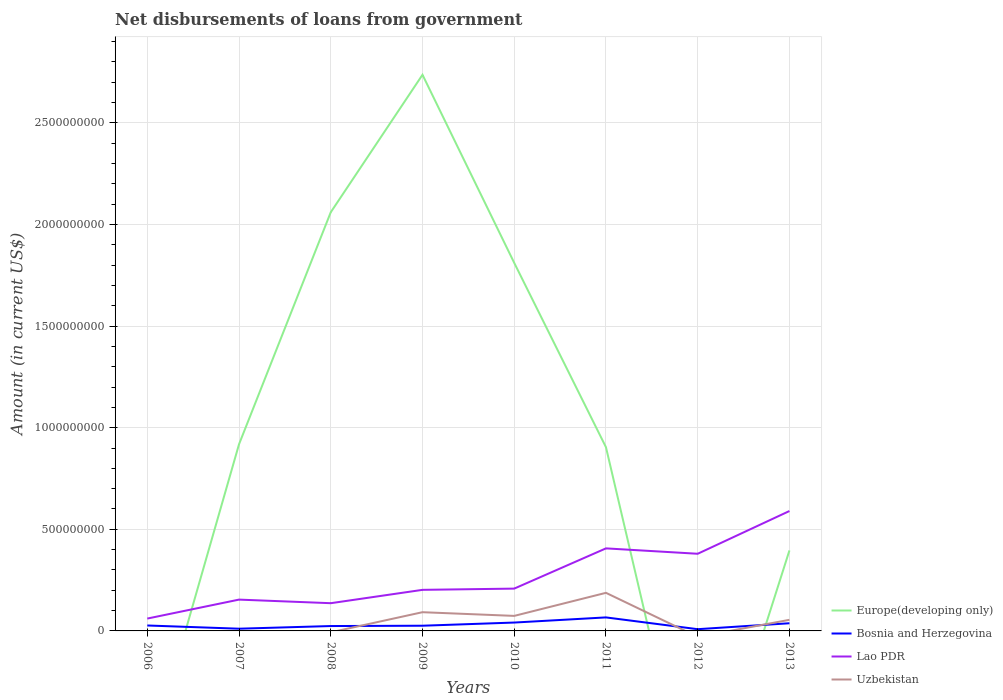Is the number of lines equal to the number of legend labels?
Keep it short and to the point. No. Across all years, what is the maximum amount of loan disbursed from government in Bosnia and Herzegovina?
Your answer should be compact. 8.51e+06. What is the total amount of loan disbursed from government in Lao PDR in the graph?
Your answer should be very brief. 1.76e+07. What is the difference between the highest and the second highest amount of loan disbursed from government in Bosnia and Herzegovina?
Provide a short and direct response. 5.80e+07. What is the difference between the highest and the lowest amount of loan disbursed from government in Europe(developing only)?
Provide a succinct answer. 3. Is the amount of loan disbursed from government in Uzbekistan strictly greater than the amount of loan disbursed from government in Bosnia and Herzegovina over the years?
Offer a terse response. No. How many lines are there?
Offer a very short reply. 4. What is the difference between two consecutive major ticks on the Y-axis?
Your answer should be compact. 5.00e+08. Does the graph contain any zero values?
Provide a succinct answer. Yes. How are the legend labels stacked?
Offer a terse response. Vertical. What is the title of the graph?
Your answer should be very brief. Net disbursements of loans from government. What is the Amount (in current US$) in Bosnia and Herzegovina in 2006?
Offer a very short reply. 2.67e+07. What is the Amount (in current US$) of Lao PDR in 2006?
Your response must be concise. 6.08e+07. What is the Amount (in current US$) in Uzbekistan in 2006?
Your answer should be compact. 0. What is the Amount (in current US$) in Europe(developing only) in 2007?
Make the answer very short. 9.19e+08. What is the Amount (in current US$) in Bosnia and Herzegovina in 2007?
Your answer should be compact. 1.09e+07. What is the Amount (in current US$) of Lao PDR in 2007?
Provide a short and direct response. 1.54e+08. What is the Amount (in current US$) of Uzbekistan in 2007?
Give a very brief answer. 0. What is the Amount (in current US$) in Europe(developing only) in 2008?
Provide a short and direct response. 2.06e+09. What is the Amount (in current US$) of Bosnia and Herzegovina in 2008?
Ensure brevity in your answer.  2.40e+07. What is the Amount (in current US$) in Lao PDR in 2008?
Offer a very short reply. 1.36e+08. What is the Amount (in current US$) of Uzbekistan in 2008?
Offer a very short reply. 0. What is the Amount (in current US$) of Europe(developing only) in 2009?
Offer a very short reply. 2.74e+09. What is the Amount (in current US$) of Bosnia and Herzegovina in 2009?
Provide a succinct answer. 2.56e+07. What is the Amount (in current US$) of Lao PDR in 2009?
Make the answer very short. 2.02e+08. What is the Amount (in current US$) in Uzbekistan in 2009?
Give a very brief answer. 9.21e+07. What is the Amount (in current US$) in Europe(developing only) in 2010?
Your answer should be very brief. 1.81e+09. What is the Amount (in current US$) in Bosnia and Herzegovina in 2010?
Provide a succinct answer. 4.12e+07. What is the Amount (in current US$) in Lao PDR in 2010?
Ensure brevity in your answer.  2.08e+08. What is the Amount (in current US$) of Uzbekistan in 2010?
Keep it short and to the point. 7.39e+07. What is the Amount (in current US$) of Europe(developing only) in 2011?
Keep it short and to the point. 9.04e+08. What is the Amount (in current US$) of Bosnia and Herzegovina in 2011?
Give a very brief answer. 6.65e+07. What is the Amount (in current US$) of Lao PDR in 2011?
Give a very brief answer. 4.06e+08. What is the Amount (in current US$) of Uzbekistan in 2011?
Provide a succinct answer. 1.87e+08. What is the Amount (in current US$) in Europe(developing only) in 2012?
Offer a very short reply. 0. What is the Amount (in current US$) in Bosnia and Herzegovina in 2012?
Offer a terse response. 8.51e+06. What is the Amount (in current US$) of Lao PDR in 2012?
Your answer should be compact. 3.80e+08. What is the Amount (in current US$) in Europe(developing only) in 2013?
Your response must be concise. 3.96e+08. What is the Amount (in current US$) of Bosnia and Herzegovina in 2013?
Your answer should be very brief. 3.77e+07. What is the Amount (in current US$) in Lao PDR in 2013?
Give a very brief answer. 5.90e+08. What is the Amount (in current US$) in Uzbekistan in 2013?
Provide a short and direct response. 5.46e+07. Across all years, what is the maximum Amount (in current US$) in Europe(developing only)?
Ensure brevity in your answer.  2.74e+09. Across all years, what is the maximum Amount (in current US$) of Bosnia and Herzegovina?
Your answer should be very brief. 6.65e+07. Across all years, what is the maximum Amount (in current US$) in Lao PDR?
Your answer should be compact. 5.90e+08. Across all years, what is the maximum Amount (in current US$) in Uzbekistan?
Offer a very short reply. 1.87e+08. Across all years, what is the minimum Amount (in current US$) in Bosnia and Herzegovina?
Provide a short and direct response. 8.51e+06. Across all years, what is the minimum Amount (in current US$) in Lao PDR?
Offer a very short reply. 6.08e+07. Across all years, what is the minimum Amount (in current US$) of Uzbekistan?
Your response must be concise. 0. What is the total Amount (in current US$) of Europe(developing only) in the graph?
Make the answer very short. 8.83e+09. What is the total Amount (in current US$) in Bosnia and Herzegovina in the graph?
Your answer should be compact. 2.41e+08. What is the total Amount (in current US$) of Lao PDR in the graph?
Your answer should be very brief. 2.14e+09. What is the total Amount (in current US$) of Uzbekistan in the graph?
Your answer should be compact. 4.08e+08. What is the difference between the Amount (in current US$) in Bosnia and Herzegovina in 2006 and that in 2007?
Offer a very short reply. 1.58e+07. What is the difference between the Amount (in current US$) of Lao PDR in 2006 and that in 2007?
Your answer should be compact. -9.33e+07. What is the difference between the Amount (in current US$) in Bosnia and Herzegovina in 2006 and that in 2008?
Your answer should be very brief. 2.72e+06. What is the difference between the Amount (in current US$) of Lao PDR in 2006 and that in 2008?
Your answer should be very brief. -7.57e+07. What is the difference between the Amount (in current US$) of Bosnia and Herzegovina in 2006 and that in 2009?
Keep it short and to the point. 1.17e+06. What is the difference between the Amount (in current US$) of Lao PDR in 2006 and that in 2009?
Give a very brief answer. -1.41e+08. What is the difference between the Amount (in current US$) of Bosnia and Herzegovina in 2006 and that in 2010?
Make the answer very short. -1.44e+07. What is the difference between the Amount (in current US$) in Lao PDR in 2006 and that in 2010?
Provide a succinct answer. -1.47e+08. What is the difference between the Amount (in current US$) in Bosnia and Herzegovina in 2006 and that in 2011?
Offer a terse response. -3.97e+07. What is the difference between the Amount (in current US$) in Lao PDR in 2006 and that in 2011?
Provide a succinct answer. -3.45e+08. What is the difference between the Amount (in current US$) of Bosnia and Herzegovina in 2006 and that in 2012?
Provide a short and direct response. 1.82e+07. What is the difference between the Amount (in current US$) of Lao PDR in 2006 and that in 2012?
Keep it short and to the point. -3.19e+08. What is the difference between the Amount (in current US$) of Bosnia and Herzegovina in 2006 and that in 2013?
Offer a very short reply. -1.10e+07. What is the difference between the Amount (in current US$) in Lao PDR in 2006 and that in 2013?
Ensure brevity in your answer.  -5.29e+08. What is the difference between the Amount (in current US$) in Europe(developing only) in 2007 and that in 2008?
Your response must be concise. -1.14e+09. What is the difference between the Amount (in current US$) in Bosnia and Herzegovina in 2007 and that in 2008?
Provide a short and direct response. -1.31e+07. What is the difference between the Amount (in current US$) in Lao PDR in 2007 and that in 2008?
Ensure brevity in your answer.  1.76e+07. What is the difference between the Amount (in current US$) in Europe(developing only) in 2007 and that in 2009?
Keep it short and to the point. -1.82e+09. What is the difference between the Amount (in current US$) of Bosnia and Herzegovina in 2007 and that in 2009?
Give a very brief answer. -1.46e+07. What is the difference between the Amount (in current US$) in Lao PDR in 2007 and that in 2009?
Provide a succinct answer. -4.80e+07. What is the difference between the Amount (in current US$) in Europe(developing only) in 2007 and that in 2010?
Give a very brief answer. -8.92e+08. What is the difference between the Amount (in current US$) in Bosnia and Herzegovina in 2007 and that in 2010?
Your answer should be compact. -3.02e+07. What is the difference between the Amount (in current US$) in Lao PDR in 2007 and that in 2010?
Your answer should be very brief. -5.42e+07. What is the difference between the Amount (in current US$) in Europe(developing only) in 2007 and that in 2011?
Keep it short and to the point. 1.46e+07. What is the difference between the Amount (in current US$) in Bosnia and Herzegovina in 2007 and that in 2011?
Your answer should be very brief. -5.56e+07. What is the difference between the Amount (in current US$) of Lao PDR in 2007 and that in 2011?
Make the answer very short. -2.52e+08. What is the difference between the Amount (in current US$) of Bosnia and Herzegovina in 2007 and that in 2012?
Your answer should be compact. 2.42e+06. What is the difference between the Amount (in current US$) of Lao PDR in 2007 and that in 2012?
Provide a short and direct response. -2.26e+08. What is the difference between the Amount (in current US$) in Europe(developing only) in 2007 and that in 2013?
Give a very brief answer. 5.22e+08. What is the difference between the Amount (in current US$) of Bosnia and Herzegovina in 2007 and that in 2013?
Ensure brevity in your answer.  -2.68e+07. What is the difference between the Amount (in current US$) in Lao PDR in 2007 and that in 2013?
Make the answer very short. -4.36e+08. What is the difference between the Amount (in current US$) of Europe(developing only) in 2008 and that in 2009?
Offer a very short reply. -6.76e+08. What is the difference between the Amount (in current US$) in Bosnia and Herzegovina in 2008 and that in 2009?
Provide a succinct answer. -1.55e+06. What is the difference between the Amount (in current US$) in Lao PDR in 2008 and that in 2009?
Provide a short and direct response. -6.57e+07. What is the difference between the Amount (in current US$) in Europe(developing only) in 2008 and that in 2010?
Give a very brief answer. 2.49e+08. What is the difference between the Amount (in current US$) in Bosnia and Herzegovina in 2008 and that in 2010?
Give a very brief answer. -1.72e+07. What is the difference between the Amount (in current US$) of Lao PDR in 2008 and that in 2010?
Ensure brevity in your answer.  -7.18e+07. What is the difference between the Amount (in current US$) in Europe(developing only) in 2008 and that in 2011?
Your answer should be very brief. 1.16e+09. What is the difference between the Amount (in current US$) in Bosnia and Herzegovina in 2008 and that in 2011?
Your answer should be compact. -4.25e+07. What is the difference between the Amount (in current US$) of Lao PDR in 2008 and that in 2011?
Give a very brief answer. -2.70e+08. What is the difference between the Amount (in current US$) in Bosnia and Herzegovina in 2008 and that in 2012?
Your answer should be compact. 1.55e+07. What is the difference between the Amount (in current US$) of Lao PDR in 2008 and that in 2012?
Give a very brief answer. -2.43e+08. What is the difference between the Amount (in current US$) of Europe(developing only) in 2008 and that in 2013?
Provide a succinct answer. 1.66e+09. What is the difference between the Amount (in current US$) of Bosnia and Herzegovina in 2008 and that in 2013?
Your answer should be very brief. -1.37e+07. What is the difference between the Amount (in current US$) in Lao PDR in 2008 and that in 2013?
Your answer should be very brief. -4.53e+08. What is the difference between the Amount (in current US$) in Europe(developing only) in 2009 and that in 2010?
Keep it short and to the point. 9.26e+08. What is the difference between the Amount (in current US$) in Bosnia and Herzegovina in 2009 and that in 2010?
Offer a very short reply. -1.56e+07. What is the difference between the Amount (in current US$) in Lao PDR in 2009 and that in 2010?
Ensure brevity in your answer.  -6.12e+06. What is the difference between the Amount (in current US$) of Uzbekistan in 2009 and that in 2010?
Ensure brevity in your answer.  1.82e+07. What is the difference between the Amount (in current US$) in Europe(developing only) in 2009 and that in 2011?
Your response must be concise. 1.83e+09. What is the difference between the Amount (in current US$) in Bosnia and Herzegovina in 2009 and that in 2011?
Provide a succinct answer. -4.09e+07. What is the difference between the Amount (in current US$) in Lao PDR in 2009 and that in 2011?
Provide a succinct answer. -2.04e+08. What is the difference between the Amount (in current US$) in Uzbekistan in 2009 and that in 2011?
Give a very brief answer. -9.53e+07. What is the difference between the Amount (in current US$) of Bosnia and Herzegovina in 2009 and that in 2012?
Your answer should be compact. 1.71e+07. What is the difference between the Amount (in current US$) of Lao PDR in 2009 and that in 2012?
Ensure brevity in your answer.  -1.78e+08. What is the difference between the Amount (in current US$) in Europe(developing only) in 2009 and that in 2013?
Your response must be concise. 2.34e+09. What is the difference between the Amount (in current US$) in Bosnia and Herzegovina in 2009 and that in 2013?
Provide a short and direct response. -1.22e+07. What is the difference between the Amount (in current US$) in Lao PDR in 2009 and that in 2013?
Offer a terse response. -3.88e+08. What is the difference between the Amount (in current US$) in Uzbekistan in 2009 and that in 2013?
Provide a succinct answer. 3.75e+07. What is the difference between the Amount (in current US$) in Europe(developing only) in 2010 and that in 2011?
Keep it short and to the point. 9.07e+08. What is the difference between the Amount (in current US$) of Bosnia and Herzegovina in 2010 and that in 2011?
Keep it short and to the point. -2.53e+07. What is the difference between the Amount (in current US$) of Lao PDR in 2010 and that in 2011?
Your answer should be very brief. -1.98e+08. What is the difference between the Amount (in current US$) of Uzbekistan in 2010 and that in 2011?
Offer a very short reply. -1.14e+08. What is the difference between the Amount (in current US$) of Bosnia and Herzegovina in 2010 and that in 2012?
Provide a succinct answer. 3.27e+07. What is the difference between the Amount (in current US$) of Lao PDR in 2010 and that in 2012?
Make the answer very short. -1.71e+08. What is the difference between the Amount (in current US$) in Europe(developing only) in 2010 and that in 2013?
Give a very brief answer. 1.41e+09. What is the difference between the Amount (in current US$) of Bosnia and Herzegovina in 2010 and that in 2013?
Provide a short and direct response. 3.44e+06. What is the difference between the Amount (in current US$) of Lao PDR in 2010 and that in 2013?
Keep it short and to the point. -3.82e+08. What is the difference between the Amount (in current US$) of Uzbekistan in 2010 and that in 2013?
Provide a succinct answer. 1.93e+07. What is the difference between the Amount (in current US$) of Bosnia and Herzegovina in 2011 and that in 2012?
Your answer should be very brief. 5.80e+07. What is the difference between the Amount (in current US$) in Lao PDR in 2011 and that in 2012?
Offer a very short reply. 2.65e+07. What is the difference between the Amount (in current US$) in Europe(developing only) in 2011 and that in 2013?
Keep it short and to the point. 5.08e+08. What is the difference between the Amount (in current US$) in Bosnia and Herzegovina in 2011 and that in 2013?
Provide a short and direct response. 2.87e+07. What is the difference between the Amount (in current US$) in Lao PDR in 2011 and that in 2013?
Offer a very short reply. -1.84e+08. What is the difference between the Amount (in current US$) in Uzbekistan in 2011 and that in 2013?
Ensure brevity in your answer.  1.33e+08. What is the difference between the Amount (in current US$) of Bosnia and Herzegovina in 2012 and that in 2013?
Provide a short and direct response. -2.92e+07. What is the difference between the Amount (in current US$) in Lao PDR in 2012 and that in 2013?
Give a very brief answer. -2.10e+08. What is the difference between the Amount (in current US$) in Bosnia and Herzegovina in 2006 and the Amount (in current US$) in Lao PDR in 2007?
Make the answer very short. -1.27e+08. What is the difference between the Amount (in current US$) in Bosnia and Herzegovina in 2006 and the Amount (in current US$) in Lao PDR in 2008?
Your response must be concise. -1.10e+08. What is the difference between the Amount (in current US$) in Bosnia and Herzegovina in 2006 and the Amount (in current US$) in Lao PDR in 2009?
Offer a very short reply. -1.75e+08. What is the difference between the Amount (in current US$) of Bosnia and Herzegovina in 2006 and the Amount (in current US$) of Uzbekistan in 2009?
Give a very brief answer. -6.54e+07. What is the difference between the Amount (in current US$) in Lao PDR in 2006 and the Amount (in current US$) in Uzbekistan in 2009?
Provide a succinct answer. -3.14e+07. What is the difference between the Amount (in current US$) of Bosnia and Herzegovina in 2006 and the Amount (in current US$) of Lao PDR in 2010?
Provide a short and direct response. -1.81e+08. What is the difference between the Amount (in current US$) of Bosnia and Herzegovina in 2006 and the Amount (in current US$) of Uzbekistan in 2010?
Offer a terse response. -4.72e+07. What is the difference between the Amount (in current US$) of Lao PDR in 2006 and the Amount (in current US$) of Uzbekistan in 2010?
Ensure brevity in your answer.  -1.32e+07. What is the difference between the Amount (in current US$) of Bosnia and Herzegovina in 2006 and the Amount (in current US$) of Lao PDR in 2011?
Your answer should be very brief. -3.79e+08. What is the difference between the Amount (in current US$) in Bosnia and Herzegovina in 2006 and the Amount (in current US$) in Uzbekistan in 2011?
Offer a terse response. -1.61e+08. What is the difference between the Amount (in current US$) of Lao PDR in 2006 and the Amount (in current US$) of Uzbekistan in 2011?
Provide a succinct answer. -1.27e+08. What is the difference between the Amount (in current US$) of Bosnia and Herzegovina in 2006 and the Amount (in current US$) of Lao PDR in 2012?
Give a very brief answer. -3.53e+08. What is the difference between the Amount (in current US$) of Bosnia and Herzegovina in 2006 and the Amount (in current US$) of Lao PDR in 2013?
Ensure brevity in your answer.  -5.63e+08. What is the difference between the Amount (in current US$) in Bosnia and Herzegovina in 2006 and the Amount (in current US$) in Uzbekistan in 2013?
Make the answer very short. -2.79e+07. What is the difference between the Amount (in current US$) of Lao PDR in 2006 and the Amount (in current US$) of Uzbekistan in 2013?
Keep it short and to the point. 6.14e+06. What is the difference between the Amount (in current US$) in Europe(developing only) in 2007 and the Amount (in current US$) in Bosnia and Herzegovina in 2008?
Make the answer very short. 8.95e+08. What is the difference between the Amount (in current US$) in Europe(developing only) in 2007 and the Amount (in current US$) in Lao PDR in 2008?
Provide a short and direct response. 7.82e+08. What is the difference between the Amount (in current US$) in Bosnia and Herzegovina in 2007 and the Amount (in current US$) in Lao PDR in 2008?
Provide a succinct answer. -1.26e+08. What is the difference between the Amount (in current US$) of Europe(developing only) in 2007 and the Amount (in current US$) of Bosnia and Herzegovina in 2009?
Keep it short and to the point. 8.93e+08. What is the difference between the Amount (in current US$) of Europe(developing only) in 2007 and the Amount (in current US$) of Lao PDR in 2009?
Ensure brevity in your answer.  7.16e+08. What is the difference between the Amount (in current US$) of Europe(developing only) in 2007 and the Amount (in current US$) of Uzbekistan in 2009?
Provide a short and direct response. 8.26e+08. What is the difference between the Amount (in current US$) in Bosnia and Herzegovina in 2007 and the Amount (in current US$) in Lao PDR in 2009?
Your answer should be compact. -1.91e+08. What is the difference between the Amount (in current US$) of Bosnia and Herzegovina in 2007 and the Amount (in current US$) of Uzbekistan in 2009?
Offer a very short reply. -8.12e+07. What is the difference between the Amount (in current US$) in Lao PDR in 2007 and the Amount (in current US$) in Uzbekistan in 2009?
Your answer should be very brief. 6.20e+07. What is the difference between the Amount (in current US$) of Europe(developing only) in 2007 and the Amount (in current US$) of Bosnia and Herzegovina in 2010?
Your response must be concise. 8.77e+08. What is the difference between the Amount (in current US$) in Europe(developing only) in 2007 and the Amount (in current US$) in Lao PDR in 2010?
Provide a succinct answer. 7.10e+08. What is the difference between the Amount (in current US$) in Europe(developing only) in 2007 and the Amount (in current US$) in Uzbekistan in 2010?
Provide a succinct answer. 8.45e+08. What is the difference between the Amount (in current US$) of Bosnia and Herzegovina in 2007 and the Amount (in current US$) of Lao PDR in 2010?
Ensure brevity in your answer.  -1.97e+08. What is the difference between the Amount (in current US$) in Bosnia and Herzegovina in 2007 and the Amount (in current US$) in Uzbekistan in 2010?
Make the answer very short. -6.30e+07. What is the difference between the Amount (in current US$) in Lao PDR in 2007 and the Amount (in current US$) in Uzbekistan in 2010?
Offer a terse response. 8.01e+07. What is the difference between the Amount (in current US$) of Europe(developing only) in 2007 and the Amount (in current US$) of Bosnia and Herzegovina in 2011?
Provide a short and direct response. 8.52e+08. What is the difference between the Amount (in current US$) in Europe(developing only) in 2007 and the Amount (in current US$) in Lao PDR in 2011?
Give a very brief answer. 5.12e+08. What is the difference between the Amount (in current US$) in Europe(developing only) in 2007 and the Amount (in current US$) in Uzbekistan in 2011?
Offer a terse response. 7.31e+08. What is the difference between the Amount (in current US$) of Bosnia and Herzegovina in 2007 and the Amount (in current US$) of Lao PDR in 2011?
Give a very brief answer. -3.95e+08. What is the difference between the Amount (in current US$) of Bosnia and Herzegovina in 2007 and the Amount (in current US$) of Uzbekistan in 2011?
Offer a terse response. -1.77e+08. What is the difference between the Amount (in current US$) of Lao PDR in 2007 and the Amount (in current US$) of Uzbekistan in 2011?
Offer a terse response. -3.34e+07. What is the difference between the Amount (in current US$) of Europe(developing only) in 2007 and the Amount (in current US$) of Bosnia and Herzegovina in 2012?
Your answer should be compact. 9.10e+08. What is the difference between the Amount (in current US$) of Europe(developing only) in 2007 and the Amount (in current US$) of Lao PDR in 2012?
Offer a terse response. 5.39e+08. What is the difference between the Amount (in current US$) of Bosnia and Herzegovina in 2007 and the Amount (in current US$) of Lao PDR in 2012?
Keep it short and to the point. -3.69e+08. What is the difference between the Amount (in current US$) of Europe(developing only) in 2007 and the Amount (in current US$) of Bosnia and Herzegovina in 2013?
Keep it short and to the point. 8.81e+08. What is the difference between the Amount (in current US$) of Europe(developing only) in 2007 and the Amount (in current US$) of Lao PDR in 2013?
Keep it short and to the point. 3.29e+08. What is the difference between the Amount (in current US$) in Europe(developing only) in 2007 and the Amount (in current US$) in Uzbekistan in 2013?
Ensure brevity in your answer.  8.64e+08. What is the difference between the Amount (in current US$) in Bosnia and Herzegovina in 2007 and the Amount (in current US$) in Lao PDR in 2013?
Offer a very short reply. -5.79e+08. What is the difference between the Amount (in current US$) of Bosnia and Herzegovina in 2007 and the Amount (in current US$) of Uzbekistan in 2013?
Ensure brevity in your answer.  -4.37e+07. What is the difference between the Amount (in current US$) in Lao PDR in 2007 and the Amount (in current US$) in Uzbekistan in 2013?
Keep it short and to the point. 9.95e+07. What is the difference between the Amount (in current US$) in Europe(developing only) in 2008 and the Amount (in current US$) in Bosnia and Herzegovina in 2009?
Your answer should be compact. 2.03e+09. What is the difference between the Amount (in current US$) of Europe(developing only) in 2008 and the Amount (in current US$) of Lao PDR in 2009?
Give a very brief answer. 1.86e+09. What is the difference between the Amount (in current US$) in Europe(developing only) in 2008 and the Amount (in current US$) in Uzbekistan in 2009?
Keep it short and to the point. 1.97e+09. What is the difference between the Amount (in current US$) in Bosnia and Herzegovina in 2008 and the Amount (in current US$) in Lao PDR in 2009?
Make the answer very short. -1.78e+08. What is the difference between the Amount (in current US$) of Bosnia and Herzegovina in 2008 and the Amount (in current US$) of Uzbekistan in 2009?
Provide a short and direct response. -6.81e+07. What is the difference between the Amount (in current US$) of Lao PDR in 2008 and the Amount (in current US$) of Uzbekistan in 2009?
Provide a short and direct response. 4.43e+07. What is the difference between the Amount (in current US$) of Europe(developing only) in 2008 and the Amount (in current US$) of Bosnia and Herzegovina in 2010?
Provide a short and direct response. 2.02e+09. What is the difference between the Amount (in current US$) of Europe(developing only) in 2008 and the Amount (in current US$) of Lao PDR in 2010?
Your response must be concise. 1.85e+09. What is the difference between the Amount (in current US$) of Europe(developing only) in 2008 and the Amount (in current US$) of Uzbekistan in 2010?
Your answer should be compact. 1.99e+09. What is the difference between the Amount (in current US$) of Bosnia and Herzegovina in 2008 and the Amount (in current US$) of Lao PDR in 2010?
Give a very brief answer. -1.84e+08. What is the difference between the Amount (in current US$) in Bosnia and Herzegovina in 2008 and the Amount (in current US$) in Uzbekistan in 2010?
Provide a short and direct response. -4.99e+07. What is the difference between the Amount (in current US$) in Lao PDR in 2008 and the Amount (in current US$) in Uzbekistan in 2010?
Offer a terse response. 6.25e+07. What is the difference between the Amount (in current US$) in Europe(developing only) in 2008 and the Amount (in current US$) in Bosnia and Herzegovina in 2011?
Your response must be concise. 1.99e+09. What is the difference between the Amount (in current US$) in Europe(developing only) in 2008 and the Amount (in current US$) in Lao PDR in 2011?
Your answer should be compact. 1.65e+09. What is the difference between the Amount (in current US$) of Europe(developing only) in 2008 and the Amount (in current US$) of Uzbekistan in 2011?
Make the answer very short. 1.87e+09. What is the difference between the Amount (in current US$) in Bosnia and Herzegovina in 2008 and the Amount (in current US$) in Lao PDR in 2011?
Offer a very short reply. -3.82e+08. What is the difference between the Amount (in current US$) of Bosnia and Herzegovina in 2008 and the Amount (in current US$) of Uzbekistan in 2011?
Your response must be concise. -1.63e+08. What is the difference between the Amount (in current US$) of Lao PDR in 2008 and the Amount (in current US$) of Uzbekistan in 2011?
Offer a terse response. -5.10e+07. What is the difference between the Amount (in current US$) of Europe(developing only) in 2008 and the Amount (in current US$) of Bosnia and Herzegovina in 2012?
Provide a succinct answer. 2.05e+09. What is the difference between the Amount (in current US$) of Europe(developing only) in 2008 and the Amount (in current US$) of Lao PDR in 2012?
Offer a very short reply. 1.68e+09. What is the difference between the Amount (in current US$) of Bosnia and Herzegovina in 2008 and the Amount (in current US$) of Lao PDR in 2012?
Offer a terse response. -3.56e+08. What is the difference between the Amount (in current US$) of Europe(developing only) in 2008 and the Amount (in current US$) of Bosnia and Herzegovina in 2013?
Your answer should be very brief. 2.02e+09. What is the difference between the Amount (in current US$) in Europe(developing only) in 2008 and the Amount (in current US$) in Lao PDR in 2013?
Ensure brevity in your answer.  1.47e+09. What is the difference between the Amount (in current US$) of Europe(developing only) in 2008 and the Amount (in current US$) of Uzbekistan in 2013?
Offer a very short reply. 2.01e+09. What is the difference between the Amount (in current US$) of Bosnia and Herzegovina in 2008 and the Amount (in current US$) of Lao PDR in 2013?
Give a very brief answer. -5.66e+08. What is the difference between the Amount (in current US$) of Bosnia and Herzegovina in 2008 and the Amount (in current US$) of Uzbekistan in 2013?
Ensure brevity in your answer.  -3.06e+07. What is the difference between the Amount (in current US$) in Lao PDR in 2008 and the Amount (in current US$) in Uzbekistan in 2013?
Provide a succinct answer. 8.18e+07. What is the difference between the Amount (in current US$) of Europe(developing only) in 2009 and the Amount (in current US$) of Bosnia and Herzegovina in 2010?
Your response must be concise. 2.70e+09. What is the difference between the Amount (in current US$) of Europe(developing only) in 2009 and the Amount (in current US$) of Lao PDR in 2010?
Provide a short and direct response. 2.53e+09. What is the difference between the Amount (in current US$) in Europe(developing only) in 2009 and the Amount (in current US$) in Uzbekistan in 2010?
Ensure brevity in your answer.  2.66e+09. What is the difference between the Amount (in current US$) in Bosnia and Herzegovina in 2009 and the Amount (in current US$) in Lao PDR in 2010?
Offer a very short reply. -1.83e+08. What is the difference between the Amount (in current US$) in Bosnia and Herzegovina in 2009 and the Amount (in current US$) in Uzbekistan in 2010?
Make the answer very short. -4.84e+07. What is the difference between the Amount (in current US$) in Lao PDR in 2009 and the Amount (in current US$) in Uzbekistan in 2010?
Provide a succinct answer. 1.28e+08. What is the difference between the Amount (in current US$) in Europe(developing only) in 2009 and the Amount (in current US$) in Bosnia and Herzegovina in 2011?
Offer a very short reply. 2.67e+09. What is the difference between the Amount (in current US$) of Europe(developing only) in 2009 and the Amount (in current US$) of Lao PDR in 2011?
Provide a succinct answer. 2.33e+09. What is the difference between the Amount (in current US$) in Europe(developing only) in 2009 and the Amount (in current US$) in Uzbekistan in 2011?
Provide a short and direct response. 2.55e+09. What is the difference between the Amount (in current US$) in Bosnia and Herzegovina in 2009 and the Amount (in current US$) in Lao PDR in 2011?
Your response must be concise. -3.81e+08. What is the difference between the Amount (in current US$) in Bosnia and Herzegovina in 2009 and the Amount (in current US$) in Uzbekistan in 2011?
Offer a very short reply. -1.62e+08. What is the difference between the Amount (in current US$) in Lao PDR in 2009 and the Amount (in current US$) in Uzbekistan in 2011?
Offer a terse response. 1.47e+07. What is the difference between the Amount (in current US$) of Europe(developing only) in 2009 and the Amount (in current US$) of Bosnia and Herzegovina in 2012?
Give a very brief answer. 2.73e+09. What is the difference between the Amount (in current US$) in Europe(developing only) in 2009 and the Amount (in current US$) in Lao PDR in 2012?
Your answer should be compact. 2.36e+09. What is the difference between the Amount (in current US$) of Bosnia and Herzegovina in 2009 and the Amount (in current US$) of Lao PDR in 2012?
Provide a succinct answer. -3.54e+08. What is the difference between the Amount (in current US$) in Europe(developing only) in 2009 and the Amount (in current US$) in Bosnia and Herzegovina in 2013?
Ensure brevity in your answer.  2.70e+09. What is the difference between the Amount (in current US$) in Europe(developing only) in 2009 and the Amount (in current US$) in Lao PDR in 2013?
Keep it short and to the point. 2.15e+09. What is the difference between the Amount (in current US$) in Europe(developing only) in 2009 and the Amount (in current US$) in Uzbekistan in 2013?
Provide a short and direct response. 2.68e+09. What is the difference between the Amount (in current US$) in Bosnia and Herzegovina in 2009 and the Amount (in current US$) in Lao PDR in 2013?
Offer a very short reply. -5.64e+08. What is the difference between the Amount (in current US$) of Bosnia and Herzegovina in 2009 and the Amount (in current US$) of Uzbekistan in 2013?
Offer a terse response. -2.90e+07. What is the difference between the Amount (in current US$) of Lao PDR in 2009 and the Amount (in current US$) of Uzbekistan in 2013?
Provide a succinct answer. 1.48e+08. What is the difference between the Amount (in current US$) of Europe(developing only) in 2010 and the Amount (in current US$) of Bosnia and Herzegovina in 2011?
Offer a very short reply. 1.74e+09. What is the difference between the Amount (in current US$) in Europe(developing only) in 2010 and the Amount (in current US$) in Lao PDR in 2011?
Offer a very short reply. 1.40e+09. What is the difference between the Amount (in current US$) of Europe(developing only) in 2010 and the Amount (in current US$) of Uzbekistan in 2011?
Keep it short and to the point. 1.62e+09. What is the difference between the Amount (in current US$) of Bosnia and Herzegovina in 2010 and the Amount (in current US$) of Lao PDR in 2011?
Provide a succinct answer. -3.65e+08. What is the difference between the Amount (in current US$) in Bosnia and Herzegovina in 2010 and the Amount (in current US$) in Uzbekistan in 2011?
Provide a succinct answer. -1.46e+08. What is the difference between the Amount (in current US$) in Lao PDR in 2010 and the Amount (in current US$) in Uzbekistan in 2011?
Offer a very short reply. 2.08e+07. What is the difference between the Amount (in current US$) of Europe(developing only) in 2010 and the Amount (in current US$) of Bosnia and Herzegovina in 2012?
Provide a short and direct response. 1.80e+09. What is the difference between the Amount (in current US$) in Europe(developing only) in 2010 and the Amount (in current US$) in Lao PDR in 2012?
Keep it short and to the point. 1.43e+09. What is the difference between the Amount (in current US$) of Bosnia and Herzegovina in 2010 and the Amount (in current US$) of Lao PDR in 2012?
Keep it short and to the point. -3.38e+08. What is the difference between the Amount (in current US$) in Europe(developing only) in 2010 and the Amount (in current US$) in Bosnia and Herzegovina in 2013?
Your response must be concise. 1.77e+09. What is the difference between the Amount (in current US$) in Europe(developing only) in 2010 and the Amount (in current US$) in Lao PDR in 2013?
Offer a terse response. 1.22e+09. What is the difference between the Amount (in current US$) of Europe(developing only) in 2010 and the Amount (in current US$) of Uzbekistan in 2013?
Offer a terse response. 1.76e+09. What is the difference between the Amount (in current US$) of Bosnia and Herzegovina in 2010 and the Amount (in current US$) of Lao PDR in 2013?
Your answer should be very brief. -5.49e+08. What is the difference between the Amount (in current US$) in Bosnia and Herzegovina in 2010 and the Amount (in current US$) in Uzbekistan in 2013?
Give a very brief answer. -1.34e+07. What is the difference between the Amount (in current US$) in Lao PDR in 2010 and the Amount (in current US$) in Uzbekistan in 2013?
Provide a short and direct response. 1.54e+08. What is the difference between the Amount (in current US$) of Europe(developing only) in 2011 and the Amount (in current US$) of Bosnia and Herzegovina in 2012?
Your response must be concise. 8.95e+08. What is the difference between the Amount (in current US$) of Europe(developing only) in 2011 and the Amount (in current US$) of Lao PDR in 2012?
Keep it short and to the point. 5.24e+08. What is the difference between the Amount (in current US$) in Bosnia and Herzegovina in 2011 and the Amount (in current US$) in Lao PDR in 2012?
Make the answer very short. -3.13e+08. What is the difference between the Amount (in current US$) in Europe(developing only) in 2011 and the Amount (in current US$) in Bosnia and Herzegovina in 2013?
Keep it short and to the point. 8.66e+08. What is the difference between the Amount (in current US$) of Europe(developing only) in 2011 and the Amount (in current US$) of Lao PDR in 2013?
Provide a succinct answer. 3.14e+08. What is the difference between the Amount (in current US$) of Europe(developing only) in 2011 and the Amount (in current US$) of Uzbekistan in 2013?
Provide a short and direct response. 8.49e+08. What is the difference between the Amount (in current US$) in Bosnia and Herzegovina in 2011 and the Amount (in current US$) in Lao PDR in 2013?
Keep it short and to the point. -5.23e+08. What is the difference between the Amount (in current US$) in Bosnia and Herzegovina in 2011 and the Amount (in current US$) in Uzbekistan in 2013?
Your answer should be very brief. 1.19e+07. What is the difference between the Amount (in current US$) of Lao PDR in 2011 and the Amount (in current US$) of Uzbekistan in 2013?
Ensure brevity in your answer.  3.52e+08. What is the difference between the Amount (in current US$) in Bosnia and Herzegovina in 2012 and the Amount (in current US$) in Lao PDR in 2013?
Keep it short and to the point. -5.81e+08. What is the difference between the Amount (in current US$) of Bosnia and Herzegovina in 2012 and the Amount (in current US$) of Uzbekistan in 2013?
Provide a short and direct response. -4.61e+07. What is the difference between the Amount (in current US$) of Lao PDR in 2012 and the Amount (in current US$) of Uzbekistan in 2013?
Provide a short and direct response. 3.25e+08. What is the average Amount (in current US$) in Europe(developing only) per year?
Provide a succinct answer. 1.10e+09. What is the average Amount (in current US$) in Bosnia and Herzegovina per year?
Your answer should be compact. 3.01e+07. What is the average Amount (in current US$) of Lao PDR per year?
Provide a short and direct response. 2.67e+08. What is the average Amount (in current US$) in Uzbekistan per year?
Keep it short and to the point. 5.10e+07. In the year 2006, what is the difference between the Amount (in current US$) in Bosnia and Herzegovina and Amount (in current US$) in Lao PDR?
Provide a succinct answer. -3.40e+07. In the year 2007, what is the difference between the Amount (in current US$) in Europe(developing only) and Amount (in current US$) in Bosnia and Herzegovina?
Provide a short and direct response. 9.08e+08. In the year 2007, what is the difference between the Amount (in current US$) in Europe(developing only) and Amount (in current US$) in Lao PDR?
Ensure brevity in your answer.  7.64e+08. In the year 2007, what is the difference between the Amount (in current US$) of Bosnia and Herzegovina and Amount (in current US$) of Lao PDR?
Your answer should be very brief. -1.43e+08. In the year 2008, what is the difference between the Amount (in current US$) in Europe(developing only) and Amount (in current US$) in Bosnia and Herzegovina?
Ensure brevity in your answer.  2.04e+09. In the year 2008, what is the difference between the Amount (in current US$) of Europe(developing only) and Amount (in current US$) of Lao PDR?
Give a very brief answer. 1.92e+09. In the year 2008, what is the difference between the Amount (in current US$) of Bosnia and Herzegovina and Amount (in current US$) of Lao PDR?
Offer a very short reply. -1.12e+08. In the year 2009, what is the difference between the Amount (in current US$) of Europe(developing only) and Amount (in current US$) of Bosnia and Herzegovina?
Keep it short and to the point. 2.71e+09. In the year 2009, what is the difference between the Amount (in current US$) of Europe(developing only) and Amount (in current US$) of Lao PDR?
Provide a short and direct response. 2.53e+09. In the year 2009, what is the difference between the Amount (in current US$) of Europe(developing only) and Amount (in current US$) of Uzbekistan?
Keep it short and to the point. 2.64e+09. In the year 2009, what is the difference between the Amount (in current US$) in Bosnia and Herzegovina and Amount (in current US$) in Lao PDR?
Give a very brief answer. -1.77e+08. In the year 2009, what is the difference between the Amount (in current US$) of Bosnia and Herzegovina and Amount (in current US$) of Uzbekistan?
Keep it short and to the point. -6.65e+07. In the year 2009, what is the difference between the Amount (in current US$) in Lao PDR and Amount (in current US$) in Uzbekistan?
Make the answer very short. 1.10e+08. In the year 2010, what is the difference between the Amount (in current US$) in Europe(developing only) and Amount (in current US$) in Bosnia and Herzegovina?
Provide a succinct answer. 1.77e+09. In the year 2010, what is the difference between the Amount (in current US$) in Europe(developing only) and Amount (in current US$) in Lao PDR?
Offer a terse response. 1.60e+09. In the year 2010, what is the difference between the Amount (in current US$) in Europe(developing only) and Amount (in current US$) in Uzbekistan?
Ensure brevity in your answer.  1.74e+09. In the year 2010, what is the difference between the Amount (in current US$) in Bosnia and Herzegovina and Amount (in current US$) in Lao PDR?
Your response must be concise. -1.67e+08. In the year 2010, what is the difference between the Amount (in current US$) in Bosnia and Herzegovina and Amount (in current US$) in Uzbekistan?
Your answer should be very brief. -3.28e+07. In the year 2010, what is the difference between the Amount (in current US$) in Lao PDR and Amount (in current US$) in Uzbekistan?
Provide a short and direct response. 1.34e+08. In the year 2011, what is the difference between the Amount (in current US$) of Europe(developing only) and Amount (in current US$) of Bosnia and Herzegovina?
Your response must be concise. 8.38e+08. In the year 2011, what is the difference between the Amount (in current US$) of Europe(developing only) and Amount (in current US$) of Lao PDR?
Provide a succinct answer. 4.98e+08. In the year 2011, what is the difference between the Amount (in current US$) in Europe(developing only) and Amount (in current US$) in Uzbekistan?
Keep it short and to the point. 7.17e+08. In the year 2011, what is the difference between the Amount (in current US$) in Bosnia and Herzegovina and Amount (in current US$) in Lao PDR?
Offer a very short reply. -3.40e+08. In the year 2011, what is the difference between the Amount (in current US$) in Bosnia and Herzegovina and Amount (in current US$) in Uzbekistan?
Keep it short and to the point. -1.21e+08. In the year 2011, what is the difference between the Amount (in current US$) in Lao PDR and Amount (in current US$) in Uzbekistan?
Provide a short and direct response. 2.19e+08. In the year 2012, what is the difference between the Amount (in current US$) in Bosnia and Herzegovina and Amount (in current US$) in Lao PDR?
Offer a terse response. -3.71e+08. In the year 2013, what is the difference between the Amount (in current US$) in Europe(developing only) and Amount (in current US$) in Bosnia and Herzegovina?
Make the answer very short. 3.58e+08. In the year 2013, what is the difference between the Amount (in current US$) of Europe(developing only) and Amount (in current US$) of Lao PDR?
Give a very brief answer. -1.94e+08. In the year 2013, what is the difference between the Amount (in current US$) in Europe(developing only) and Amount (in current US$) in Uzbekistan?
Provide a succinct answer. 3.41e+08. In the year 2013, what is the difference between the Amount (in current US$) of Bosnia and Herzegovina and Amount (in current US$) of Lao PDR?
Offer a very short reply. -5.52e+08. In the year 2013, what is the difference between the Amount (in current US$) of Bosnia and Herzegovina and Amount (in current US$) of Uzbekistan?
Your response must be concise. -1.69e+07. In the year 2013, what is the difference between the Amount (in current US$) of Lao PDR and Amount (in current US$) of Uzbekistan?
Your answer should be compact. 5.35e+08. What is the ratio of the Amount (in current US$) of Bosnia and Herzegovina in 2006 to that in 2007?
Provide a succinct answer. 2.45. What is the ratio of the Amount (in current US$) of Lao PDR in 2006 to that in 2007?
Your answer should be very brief. 0.39. What is the ratio of the Amount (in current US$) in Bosnia and Herzegovina in 2006 to that in 2008?
Ensure brevity in your answer.  1.11. What is the ratio of the Amount (in current US$) in Lao PDR in 2006 to that in 2008?
Provide a short and direct response. 0.45. What is the ratio of the Amount (in current US$) in Bosnia and Herzegovina in 2006 to that in 2009?
Make the answer very short. 1.05. What is the ratio of the Amount (in current US$) in Lao PDR in 2006 to that in 2009?
Give a very brief answer. 0.3. What is the ratio of the Amount (in current US$) of Bosnia and Herzegovina in 2006 to that in 2010?
Your response must be concise. 0.65. What is the ratio of the Amount (in current US$) in Lao PDR in 2006 to that in 2010?
Your answer should be very brief. 0.29. What is the ratio of the Amount (in current US$) of Bosnia and Herzegovina in 2006 to that in 2011?
Your response must be concise. 0.4. What is the ratio of the Amount (in current US$) of Lao PDR in 2006 to that in 2011?
Keep it short and to the point. 0.15. What is the ratio of the Amount (in current US$) of Bosnia and Herzegovina in 2006 to that in 2012?
Provide a succinct answer. 3.14. What is the ratio of the Amount (in current US$) in Lao PDR in 2006 to that in 2012?
Keep it short and to the point. 0.16. What is the ratio of the Amount (in current US$) of Bosnia and Herzegovina in 2006 to that in 2013?
Ensure brevity in your answer.  0.71. What is the ratio of the Amount (in current US$) of Lao PDR in 2006 to that in 2013?
Make the answer very short. 0.1. What is the ratio of the Amount (in current US$) in Europe(developing only) in 2007 to that in 2008?
Give a very brief answer. 0.45. What is the ratio of the Amount (in current US$) in Bosnia and Herzegovina in 2007 to that in 2008?
Provide a succinct answer. 0.46. What is the ratio of the Amount (in current US$) of Lao PDR in 2007 to that in 2008?
Offer a terse response. 1.13. What is the ratio of the Amount (in current US$) of Europe(developing only) in 2007 to that in 2009?
Your response must be concise. 0.34. What is the ratio of the Amount (in current US$) of Bosnia and Herzegovina in 2007 to that in 2009?
Make the answer very short. 0.43. What is the ratio of the Amount (in current US$) of Lao PDR in 2007 to that in 2009?
Your answer should be very brief. 0.76. What is the ratio of the Amount (in current US$) of Europe(developing only) in 2007 to that in 2010?
Your answer should be compact. 0.51. What is the ratio of the Amount (in current US$) of Bosnia and Herzegovina in 2007 to that in 2010?
Ensure brevity in your answer.  0.27. What is the ratio of the Amount (in current US$) in Lao PDR in 2007 to that in 2010?
Provide a succinct answer. 0.74. What is the ratio of the Amount (in current US$) in Europe(developing only) in 2007 to that in 2011?
Offer a terse response. 1.02. What is the ratio of the Amount (in current US$) of Bosnia and Herzegovina in 2007 to that in 2011?
Give a very brief answer. 0.16. What is the ratio of the Amount (in current US$) of Lao PDR in 2007 to that in 2011?
Your answer should be very brief. 0.38. What is the ratio of the Amount (in current US$) of Bosnia and Herzegovina in 2007 to that in 2012?
Keep it short and to the point. 1.28. What is the ratio of the Amount (in current US$) of Lao PDR in 2007 to that in 2012?
Keep it short and to the point. 0.41. What is the ratio of the Amount (in current US$) of Europe(developing only) in 2007 to that in 2013?
Your answer should be compact. 2.32. What is the ratio of the Amount (in current US$) in Bosnia and Herzegovina in 2007 to that in 2013?
Keep it short and to the point. 0.29. What is the ratio of the Amount (in current US$) in Lao PDR in 2007 to that in 2013?
Provide a succinct answer. 0.26. What is the ratio of the Amount (in current US$) of Europe(developing only) in 2008 to that in 2009?
Your response must be concise. 0.75. What is the ratio of the Amount (in current US$) of Bosnia and Herzegovina in 2008 to that in 2009?
Offer a very short reply. 0.94. What is the ratio of the Amount (in current US$) in Lao PDR in 2008 to that in 2009?
Provide a short and direct response. 0.68. What is the ratio of the Amount (in current US$) in Europe(developing only) in 2008 to that in 2010?
Make the answer very short. 1.14. What is the ratio of the Amount (in current US$) of Bosnia and Herzegovina in 2008 to that in 2010?
Ensure brevity in your answer.  0.58. What is the ratio of the Amount (in current US$) of Lao PDR in 2008 to that in 2010?
Your answer should be very brief. 0.66. What is the ratio of the Amount (in current US$) in Europe(developing only) in 2008 to that in 2011?
Your answer should be very brief. 2.28. What is the ratio of the Amount (in current US$) in Bosnia and Herzegovina in 2008 to that in 2011?
Offer a very short reply. 0.36. What is the ratio of the Amount (in current US$) of Lao PDR in 2008 to that in 2011?
Give a very brief answer. 0.34. What is the ratio of the Amount (in current US$) of Bosnia and Herzegovina in 2008 to that in 2012?
Give a very brief answer. 2.82. What is the ratio of the Amount (in current US$) in Lao PDR in 2008 to that in 2012?
Your answer should be compact. 0.36. What is the ratio of the Amount (in current US$) of Europe(developing only) in 2008 to that in 2013?
Your response must be concise. 5.2. What is the ratio of the Amount (in current US$) in Bosnia and Herzegovina in 2008 to that in 2013?
Give a very brief answer. 0.64. What is the ratio of the Amount (in current US$) in Lao PDR in 2008 to that in 2013?
Your answer should be compact. 0.23. What is the ratio of the Amount (in current US$) of Europe(developing only) in 2009 to that in 2010?
Your answer should be compact. 1.51. What is the ratio of the Amount (in current US$) in Bosnia and Herzegovina in 2009 to that in 2010?
Your answer should be compact. 0.62. What is the ratio of the Amount (in current US$) of Lao PDR in 2009 to that in 2010?
Keep it short and to the point. 0.97. What is the ratio of the Amount (in current US$) in Uzbekistan in 2009 to that in 2010?
Your response must be concise. 1.25. What is the ratio of the Amount (in current US$) in Europe(developing only) in 2009 to that in 2011?
Make the answer very short. 3.03. What is the ratio of the Amount (in current US$) of Bosnia and Herzegovina in 2009 to that in 2011?
Provide a short and direct response. 0.38. What is the ratio of the Amount (in current US$) of Lao PDR in 2009 to that in 2011?
Give a very brief answer. 0.5. What is the ratio of the Amount (in current US$) of Uzbekistan in 2009 to that in 2011?
Give a very brief answer. 0.49. What is the ratio of the Amount (in current US$) of Bosnia and Herzegovina in 2009 to that in 2012?
Offer a very short reply. 3. What is the ratio of the Amount (in current US$) of Lao PDR in 2009 to that in 2012?
Provide a short and direct response. 0.53. What is the ratio of the Amount (in current US$) in Europe(developing only) in 2009 to that in 2013?
Offer a terse response. 6.91. What is the ratio of the Amount (in current US$) of Bosnia and Herzegovina in 2009 to that in 2013?
Make the answer very short. 0.68. What is the ratio of the Amount (in current US$) in Lao PDR in 2009 to that in 2013?
Your response must be concise. 0.34. What is the ratio of the Amount (in current US$) of Uzbekistan in 2009 to that in 2013?
Offer a very short reply. 1.69. What is the ratio of the Amount (in current US$) in Europe(developing only) in 2010 to that in 2011?
Offer a terse response. 2. What is the ratio of the Amount (in current US$) in Bosnia and Herzegovina in 2010 to that in 2011?
Give a very brief answer. 0.62. What is the ratio of the Amount (in current US$) in Lao PDR in 2010 to that in 2011?
Offer a very short reply. 0.51. What is the ratio of the Amount (in current US$) of Uzbekistan in 2010 to that in 2011?
Make the answer very short. 0.39. What is the ratio of the Amount (in current US$) in Bosnia and Herzegovina in 2010 to that in 2012?
Provide a succinct answer. 4.84. What is the ratio of the Amount (in current US$) of Lao PDR in 2010 to that in 2012?
Offer a terse response. 0.55. What is the ratio of the Amount (in current US$) of Europe(developing only) in 2010 to that in 2013?
Provide a short and direct response. 4.57. What is the ratio of the Amount (in current US$) in Bosnia and Herzegovina in 2010 to that in 2013?
Your answer should be compact. 1.09. What is the ratio of the Amount (in current US$) in Lao PDR in 2010 to that in 2013?
Your answer should be very brief. 0.35. What is the ratio of the Amount (in current US$) of Uzbekistan in 2010 to that in 2013?
Give a very brief answer. 1.35. What is the ratio of the Amount (in current US$) in Bosnia and Herzegovina in 2011 to that in 2012?
Give a very brief answer. 7.81. What is the ratio of the Amount (in current US$) of Lao PDR in 2011 to that in 2012?
Your answer should be compact. 1.07. What is the ratio of the Amount (in current US$) in Europe(developing only) in 2011 to that in 2013?
Ensure brevity in your answer.  2.28. What is the ratio of the Amount (in current US$) of Bosnia and Herzegovina in 2011 to that in 2013?
Provide a short and direct response. 1.76. What is the ratio of the Amount (in current US$) of Lao PDR in 2011 to that in 2013?
Offer a very short reply. 0.69. What is the ratio of the Amount (in current US$) of Uzbekistan in 2011 to that in 2013?
Provide a short and direct response. 3.43. What is the ratio of the Amount (in current US$) in Bosnia and Herzegovina in 2012 to that in 2013?
Make the answer very short. 0.23. What is the ratio of the Amount (in current US$) in Lao PDR in 2012 to that in 2013?
Make the answer very short. 0.64. What is the difference between the highest and the second highest Amount (in current US$) in Europe(developing only)?
Your answer should be compact. 6.76e+08. What is the difference between the highest and the second highest Amount (in current US$) in Bosnia and Herzegovina?
Offer a terse response. 2.53e+07. What is the difference between the highest and the second highest Amount (in current US$) of Lao PDR?
Your answer should be very brief. 1.84e+08. What is the difference between the highest and the second highest Amount (in current US$) in Uzbekistan?
Offer a very short reply. 9.53e+07. What is the difference between the highest and the lowest Amount (in current US$) in Europe(developing only)?
Provide a short and direct response. 2.74e+09. What is the difference between the highest and the lowest Amount (in current US$) of Bosnia and Herzegovina?
Offer a very short reply. 5.80e+07. What is the difference between the highest and the lowest Amount (in current US$) of Lao PDR?
Keep it short and to the point. 5.29e+08. What is the difference between the highest and the lowest Amount (in current US$) of Uzbekistan?
Your answer should be very brief. 1.87e+08. 